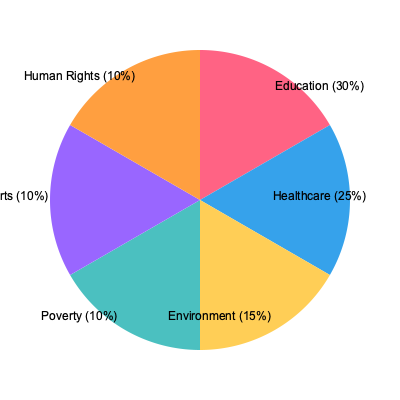As a visionary leader overseeing fund distribution, you are presented with a pie chart showing the allocation of funds to different charitable sectors. If the total amount of funds is $10 million, how much money is allocated to the Healthcare sector? To solve this problem, we need to follow these steps:

1. Identify the percentage allocated to the Healthcare sector from the pie chart.
   The pie chart shows that Healthcare is allocated 25% of the total funds.

2. Calculate the amount of money allocated to Healthcare:
   - Total funds: $10 million
   - Percentage for Healthcare: 25%
   
   To calculate the amount, we use the formula:
   $\text{Amount} = \text{Total Funds} \times \text{Percentage}$

   $\text{Amount} = \$10,000,000 \times 25\%$
   
   $\text{Amount} = \$10,000,000 \times 0.25$
   
   $\text{Amount} = \$2,500,000$

Therefore, the amount of money allocated to the Healthcare sector is $2,500,000.
Answer: $2,500,000 